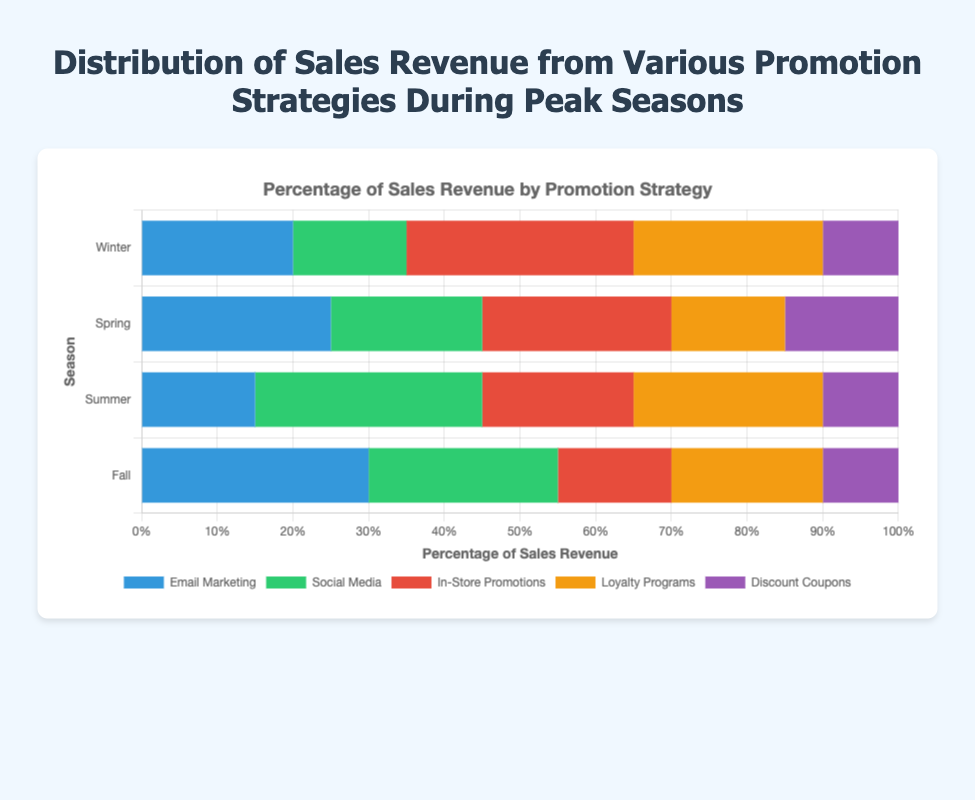Which season has the highest sales revenue from Email Marketing? To find this, we need to compare the Email Marketing sales revenue for all seasons: Winter (20), Spring (25), Summer (15), and Fall (30). Fall has the highest value.
Answer: Fall What is the total percentage of sales revenue from Loyalty Programs in Winter and Summer combined? For this, we add the sales revenue percentages of Loyalty Programs for Winter (25) and Summer (25). 25 + 25 equals 50.
Answer: 50% Which promotion strategy generated the least revenue in Spring? To determine this, we look at the percentages for each promotion strategy in Spring: Email Marketing (25), Social Media (20), In-Store Promotions (25), Loyalty Programs (15), and Discount Coupons (15). Both Loyalty Programs and Discount Coupons generated the least revenue (15%).
Answer: Loyalty Programs and Discount Coupons Compare the sales revenue from Social Media in Summer and Fall. Which season has a higher revenue, and by how much? During Summer, Social Media generates 30% of the revenue, while in Fall, it generates 25%. So, comparing the two, Summer has higher revenue by 5%. 30 - 25 equals 5.
Answer: Summer by 5% What is the average percentage of sales revenue generated by In-Store Promotions across all seasons? First, we note the sales revenue percentages for In-Store Promotions in all seasons: Winter (30), Spring (25), Summer (20), Fall (15). Summing these, (30 + 25 + 20 + 15) equals 90. There are 4 seasons, so we divide 90 by 4 to get the average. 90 / 4 equals 22.5.
Answer: 22.5% Which promotion strategy consistently generates around 10% of sales revenue in all seasons? Looking at the chart, Discount Coupons generate about 10% in Winter, Spring, Summer, and Fall.
Answer: Discount Coupons What is the difference in sales revenue generated by Email Marketing between Winter and Summer? Comparing Winter (20%) to Summer (15%), Email Marketing generates 5% more revenue in Winter. 20 - 15 equals 5.
Answer: 5% Which promotion strategy shows a significant increase in revenue from Winter to Fall? For Email Marketing, the revenue increases from 20% in Winter to 30% in Fall, showing a significant increase.
Answer: Email Marketing What is the combined percentage of sales revenue from Social Media and Loyalty Programs in Spring? In Spring, Social Media generates 20% and Loyalty Programs generate 15%. Adding these together, 20 + 15 equals 35%.
Answer: 35% Between Winter and Fall, which season has a higher combined revenue from Email Marketing and In-Store Promotions, and by how much? In Winter, the combined revenue is 20% (Email Marketing) + 30% (In-Store Promotions) = 50%. In Fall, it's 30% (Email Marketing) + 15% (In-Store Promotions) = 45%. Winter has a higher combined revenue. 50 - 45 equals 5%.
Answer: Winter by 5% 